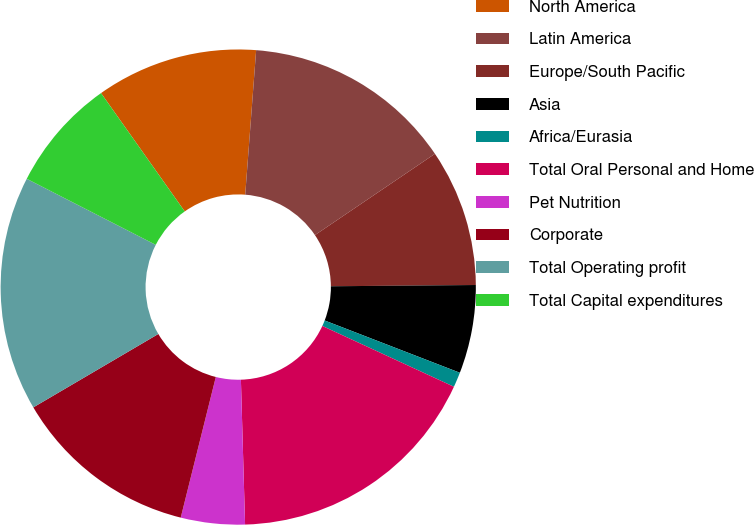<chart> <loc_0><loc_0><loc_500><loc_500><pie_chart><fcel>North America<fcel>Latin America<fcel>Europe/South Pacific<fcel>Asia<fcel>Africa/Eurasia<fcel>Total Oral Personal and Home<fcel>Pet Nutrition<fcel>Corporate<fcel>Total Operating profit<fcel>Total Capital expenditures<nl><fcel>11.0%<fcel>14.32%<fcel>9.34%<fcel>6.01%<fcel>1.02%<fcel>17.65%<fcel>4.35%<fcel>12.66%<fcel>15.98%<fcel>7.67%<nl></chart> 